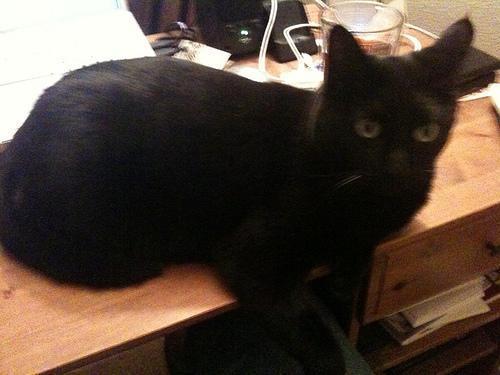How many cats are shown?
Give a very brief answer. 1. 